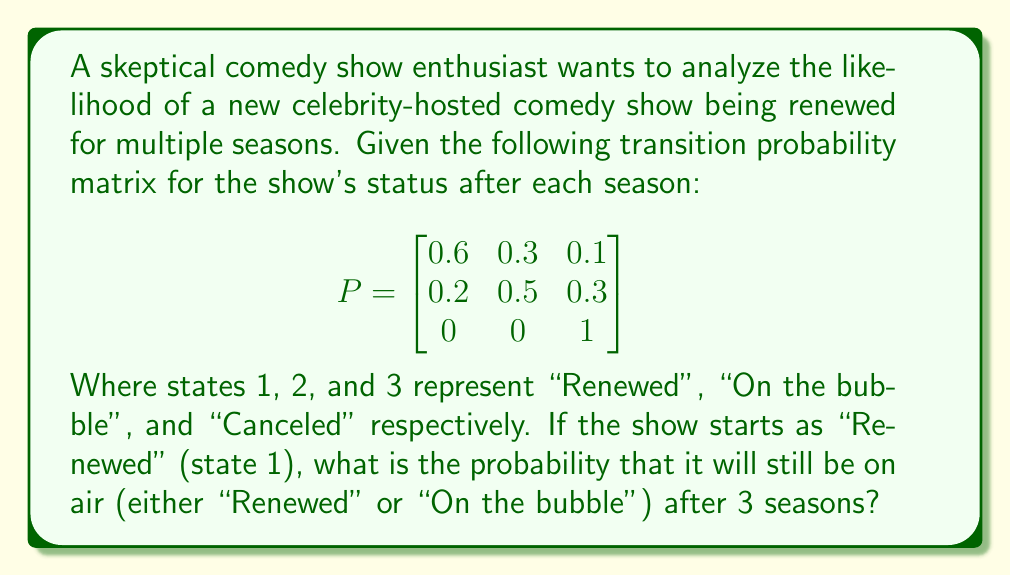Solve this math problem. To solve this problem, we need to use Markov chains and matrix multiplication. Let's follow these steps:

1) First, we need to calculate $P^3$, which represents the transition probabilities after 3 seasons. We can do this by multiplying P by itself three times:

   $P^3 = P \times P \times P$

2) Using a calculator or computer algebra system, we get:

   $$P^3 = \begin{bmatrix}
   0.312 & 0.393 & 0.295 \\
   0.208 & 0.397 & 0.395 \\
   0 & 0 & 1
   \end{bmatrix}$$

3) The initial state vector is $[1, 0, 0]$ since the show starts in the "Renewed" state.

4) To find the probabilities after 3 seasons, we multiply the initial state vector by $P^3$:

   $[1, 0, 0] \times \begin{bmatrix}
   0.312 & 0.393 & 0.295 \\
   0.208 & 0.397 & 0.395 \\
   0 & 0 & 1
   \end{bmatrix} = [0.312, 0.393, 0.295]$

5) The probability of the show still being on air after 3 seasons is the sum of the probabilities of being in state 1 ("Renewed") or state 2 ("On the bubble"):

   $0.312 + 0.393 = 0.705$

Therefore, the probability that the show will still be on air after 3 seasons is 0.705 or 70.5%.
Answer: 0.705 